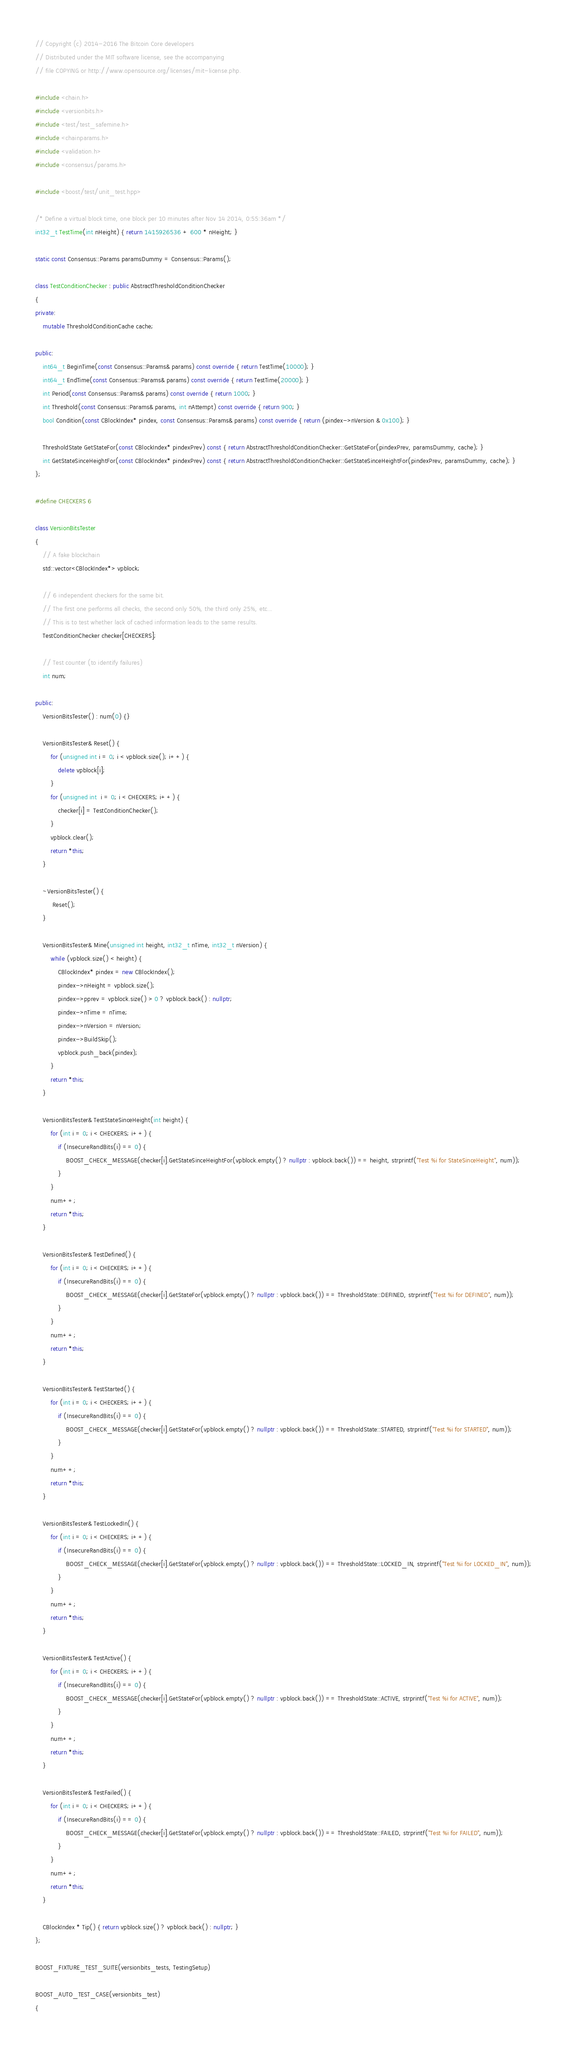<code> <loc_0><loc_0><loc_500><loc_500><_C++_>// Copyright (c) 2014-2016 The Bitcoin Core developers
// Distributed under the MIT software license, see the accompanying
// file COPYING or http://www.opensource.org/licenses/mit-license.php.

#include <chain.h>
#include <versionbits.h>
#include <test/test_safemine.h>
#include <chainparams.h>
#include <validation.h>
#include <consensus/params.h>

#include <boost/test/unit_test.hpp>

/* Define a virtual block time, one block per 10 minutes after Nov 14 2014, 0:55:36am */
int32_t TestTime(int nHeight) { return 1415926536 + 600 * nHeight; }

static const Consensus::Params paramsDummy = Consensus::Params();

class TestConditionChecker : public AbstractThresholdConditionChecker
{
private:
    mutable ThresholdConditionCache cache;

public:
    int64_t BeginTime(const Consensus::Params& params) const override { return TestTime(10000); }
    int64_t EndTime(const Consensus::Params& params) const override { return TestTime(20000); }
    int Period(const Consensus::Params& params) const override { return 1000; }
    int Threshold(const Consensus::Params& params, int nAttempt) const override { return 900; }
    bool Condition(const CBlockIndex* pindex, const Consensus::Params& params) const override { return (pindex->nVersion & 0x100); }

    ThresholdState GetStateFor(const CBlockIndex* pindexPrev) const { return AbstractThresholdConditionChecker::GetStateFor(pindexPrev, paramsDummy, cache); }
    int GetStateSinceHeightFor(const CBlockIndex* pindexPrev) const { return AbstractThresholdConditionChecker::GetStateSinceHeightFor(pindexPrev, paramsDummy, cache); }
};

#define CHECKERS 6

class VersionBitsTester
{
    // A fake blockchain
    std::vector<CBlockIndex*> vpblock;

    // 6 independent checkers for the same bit.
    // The first one performs all checks, the second only 50%, the third only 25%, etc...
    // This is to test whether lack of cached information leads to the same results.
    TestConditionChecker checker[CHECKERS];

    // Test counter (to identify failures)
    int num;

public:
    VersionBitsTester() : num(0) {}

    VersionBitsTester& Reset() {
        for (unsigned int i = 0; i < vpblock.size(); i++) {
            delete vpblock[i];
        }
        for (unsigned int  i = 0; i < CHECKERS; i++) {
            checker[i] = TestConditionChecker();
        }
        vpblock.clear();
        return *this;
    }

    ~VersionBitsTester() {
         Reset();
    }

    VersionBitsTester& Mine(unsigned int height, int32_t nTime, int32_t nVersion) {
        while (vpblock.size() < height) {
            CBlockIndex* pindex = new CBlockIndex();
            pindex->nHeight = vpblock.size();
            pindex->pprev = vpblock.size() > 0 ? vpblock.back() : nullptr;
            pindex->nTime = nTime;
            pindex->nVersion = nVersion;
            pindex->BuildSkip();
            vpblock.push_back(pindex);
        }
        return *this;
    }

    VersionBitsTester& TestStateSinceHeight(int height) {
        for (int i = 0; i < CHECKERS; i++) {
            if (InsecureRandBits(i) == 0) {
                BOOST_CHECK_MESSAGE(checker[i].GetStateSinceHeightFor(vpblock.empty() ? nullptr : vpblock.back()) == height, strprintf("Test %i for StateSinceHeight", num));
            }
        }
        num++;
        return *this;
    }

    VersionBitsTester& TestDefined() {
        for (int i = 0; i < CHECKERS; i++) {
            if (InsecureRandBits(i) == 0) {
                BOOST_CHECK_MESSAGE(checker[i].GetStateFor(vpblock.empty() ? nullptr : vpblock.back()) == ThresholdState::DEFINED, strprintf("Test %i for DEFINED", num));
            }
        }
        num++;
        return *this;
    }

    VersionBitsTester& TestStarted() {
        for (int i = 0; i < CHECKERS; i++) {
            if (InsecureRandBits(i) == 0) {
                BOOST_CHECK_MESSAGE(checker[i].GetStateFor(vpblock.empty() ? nullptr : vpblock.back()) == ThresholdState::STARTED, strprintf("Test %i for STARTED", num));
            }
        }
        num++;
        return *this;
    }

    VersionBitsTester& TestLockedIn() {
        for (int i = 0; i < CHECKERS; i++) {
            if (InsecureRandBits(i) == 0) {
                BOOST_CHECK_MESSAGE(checker[i].GetStateFor(vpblock.empty() ? nullptr : vpblock.back()) == ThresholdState::LOCKED_IN, strprintf("Test %i for LOCKED_IN", num));
            }
        }
        num++;
        return *this;
    }

    VersionBitsTester& TestActive() {
        for (int i = 0; i < CHECKERS; i++) {
            if (InsecureRandBits(i) == 0) {
                BOOST_CHECK_MESSAGE(checker[i].GetStateFor(vpblock.empty() ? nullptr : vpblock.back()) == ThresholdState::ACTIVE, strprintf("Test %i for ACTIVE", num));
            }
        }
        num++;
        return *this;
    }

    VersionBitsTester& TestFailed() {
        for (int i = 0; i < CHECKERS; i++) {
            if (InsecureRandBits(i) == 0) {
                BOOST_CHECK_MESSAGE(checker[i].GetStateFor(vpblock.empty() ? nullptr : vpblock.back()) == ThresholdState::FAILED, strprintf("Test %i for FAILED", num));
            }
        }
        num++;
        return *this;
    }

    CBlockIndex * Tip() { return vpblock.size() ? vpblock.back() : nullptr; }
};

BOOST_FIXTURE_TEST_SUITE(versionbits_tests, TestingSetup)

BOOST_AUTO_TEST_CASE(versionbits_test)
{</code> 